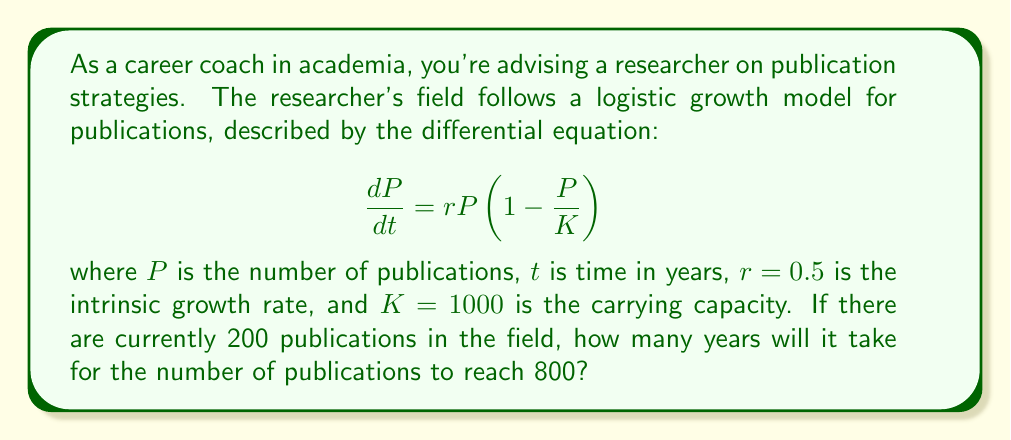Provide a solution to this math problem. To solve this problem, we need to integrate the logistic differential equation and solve for time. Let's approach this step-by-step:

1) The logistic differential equation is:

   $$\frac{dP}{dt} = rP(1 - \frac{P}{K})$$

2) Separating variables:

   $$\frac{dP}{P(1 - \frac{P}{K})} = rdt$$

3) Integrating both sides:

   $$\int_{P_0}^{P} \frac{dP}{P(1 - \frac{P}{K})} = \int_{0}^{t} rdt$$

4) The left-hand side integrates to:

   $$\ln|\frac{P}{K-P}| - \ln|\frac{P_0}{K-P_0}| = rt$$

5) Simplifying and solving for $P$:

   $$\frac{P}{K-P} = \frac{P_0}{K-P_0}e^{rt}$$

   $$P = \frac{KP_0e^{rt}}{K-P_0+P_0e^{rt}}$$

6) Substituting the given values ($P_0 = 200$, $K = 1000$, $r = 0.5$, $P = 800$):

   $$800 = \frac{1000 \cdot 200e^{0.5t}}{1000-200+200e^{0.5t}}$$

7) Solving for $t$:

   $$800(800+200e^{0.5t}) = 200000e^{0.5t}$$
   $$640000 + 160000e^{0.5t} = 200000e^{0.5t}$$
   $$640000 = 40000e^{0.5t}$$
   $$16 = e^{0.5t}$$
   $$\ln(16) = 0.5t$$
   $$t = \frac{2\ln(16)}{0.5} \approx 11.09$$

Therefore, it will take approximately 11.09 years for the number of publications to reach 800.
Answer: 11.09 years 